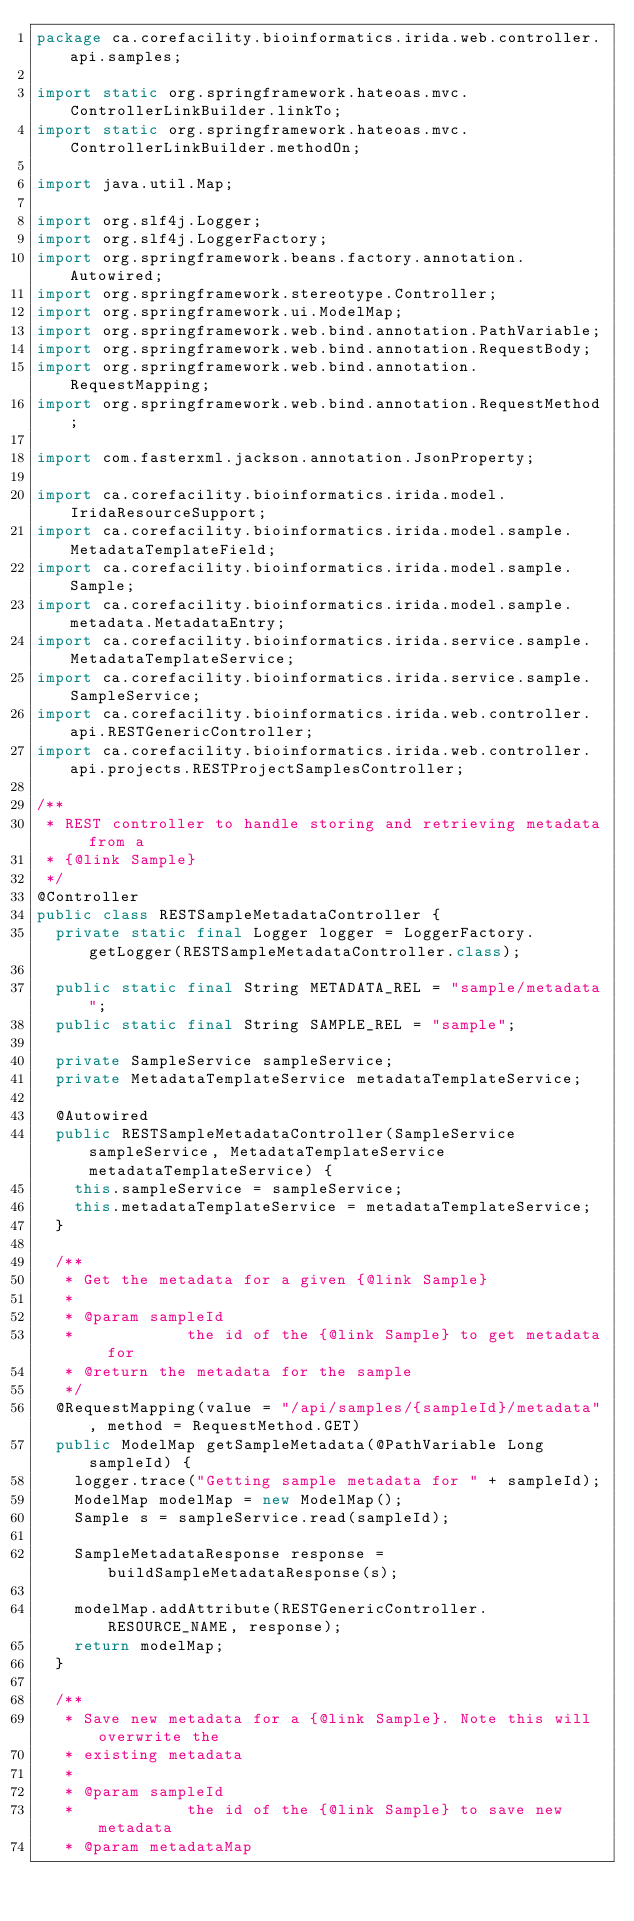Convert code to text. <code><loc_0><loc_0><loc_500><loc_500><_Java_>package ca.corefacility.bioinformatics.irida.web.controller.api.samples;

import static org.springframework.hateoas.mvc.ControllerLinkBuilder.linkTo;
import static org.springframework.hateoas.mvc.ControllerLinkBuilder.methodOn;

import java.util.Map;

import org.slf4j.Logger;
import org.slf4j.LoggerFactory;
import org.springframework.beans.factory.annotation.Autowired;
import org.springframework.stereotype.Controller;
import org.springframework.ui.ModelMap;
import org.springframework.web.bind.annotation.PathVariable;
import org.springframework.web.bind.annotation.RequestBody;
import org.springframework.web.bind.annotation.RequestMapping;
import org.springframework.web.bind.annotation.RequestMethod;

import com.fasterxml.jackson.annotation.JsonProperty;

import ca.corefacility.bioinformatics.irida.model.IridaResourceSupport;
import ca.corefacility.bioinformatics.irida.model.sample.MetadataTemplateField;
import ca.corefacility.bioinformatics.irida.model.sample.Sample;
import ca.corefacility.bioinformatics.irida.model.sample.metadata.MetadataEntry;
import ca.corefacility.bioinformatics.irida.service.sample.MetadataTemplateService;
import ca.corefacility.bioinformatics.irida.service.sample.SampleService;
import ca.corefacility.bioinformatics.irida.web.controller.api.RESTGenericController;
import ca.corefacility.bioinformatics.irida.web.controller.api.projects.RESTProjectSamplesController;

/**
 * REST controller to handle storing and retrieving metadata from a
 * {@link Sample}
 */
@Controller
public class RESTSampleMetadataController {
	private static final Logger logger = LoggerFactory.getLogger(RESTSampleMetadataController.class);

	public static final String METADATA_REL = "sample/metadata";
	public static final String SAMPLE_REL = "sample";

	private SampleService sampleService;
	private MetadataTemplateService metadataTemplateService;

	@Autowired
	public RESTSampleMetadataController(SampleService sampleService, MetadataTemplateService metadataTemplateService) {
		this.sampleService = sampleService;
		this.metadataTemplateService = metadataTemplateService;
	}

	/**
	 * Get the metadata for a given {@link Sample}
	 * 
	 * @param sampleId
	 *            the id of the {@link Sample} to get metadata for
	 * @return the metadata for the sample
	 */
	@RequestMapping(value = "/api/samples/{sampleId}/metadata", method = RequestMethod.GET)
	public ModelMap getSampleMetadata(@PathVariable Long sampleId) {
		logger.trace("Getting sample metadata for " + sampleId);
		ModelMap modelMap = new ModelMap();
		Sample s = sampleService.read(sampleId);

		SampleMetadataResponse response = buildSampleMetadataResponse(s);

		modelMap.addAttribute(RESTGenericController.RESOURCE_NAME, response);
		return modelMap;
	}

	/**
	 * Save new metadata for a {@link Sample}. Note this will overwrite the
	 * existing metadata
	 * 
	 * @param sampleId
	 *            the id of the {@link Sample} to save new metadata
	 * @param metadataMap</code> 